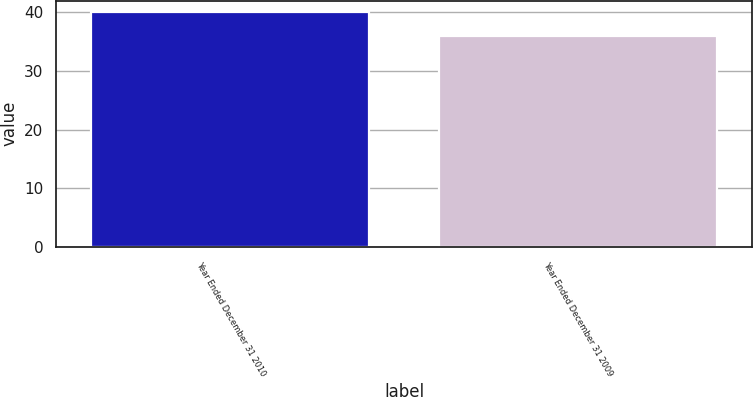Convert chart to OTSL. <chart><loc_0><loc_0><loc_500><loc_500><bar_chart><fcel>Year Ended December 31 2010<fcel>Year Ended December 31 2009<nl><fcel>40<fcel>36<nl></chart> 